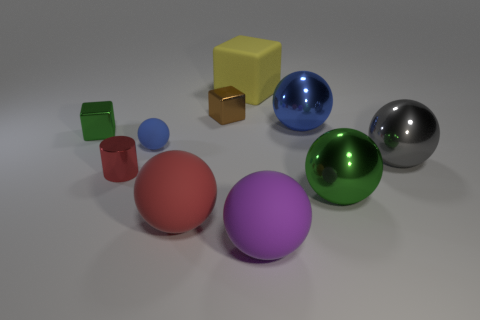Subtract all large gray metal spheres. How many spheres are left? 5 Subtract all blue balls. How many balls are left? 4 Subtract all yellow spheres. Subtract all gray cubes. How many spheres are left? 6 Subtract all blocks. How many objects are left? 7 Subtract 0 red blocks. How many objects are left? 10 Subtract all small purple spheres. Subtract all tiny red metallic cylinders. How many objects are left? 9 Add 4 gray spheres. How many gray spheres are left? 5 Add 5 large blue spheres. How many large blue spheres exist? 6 